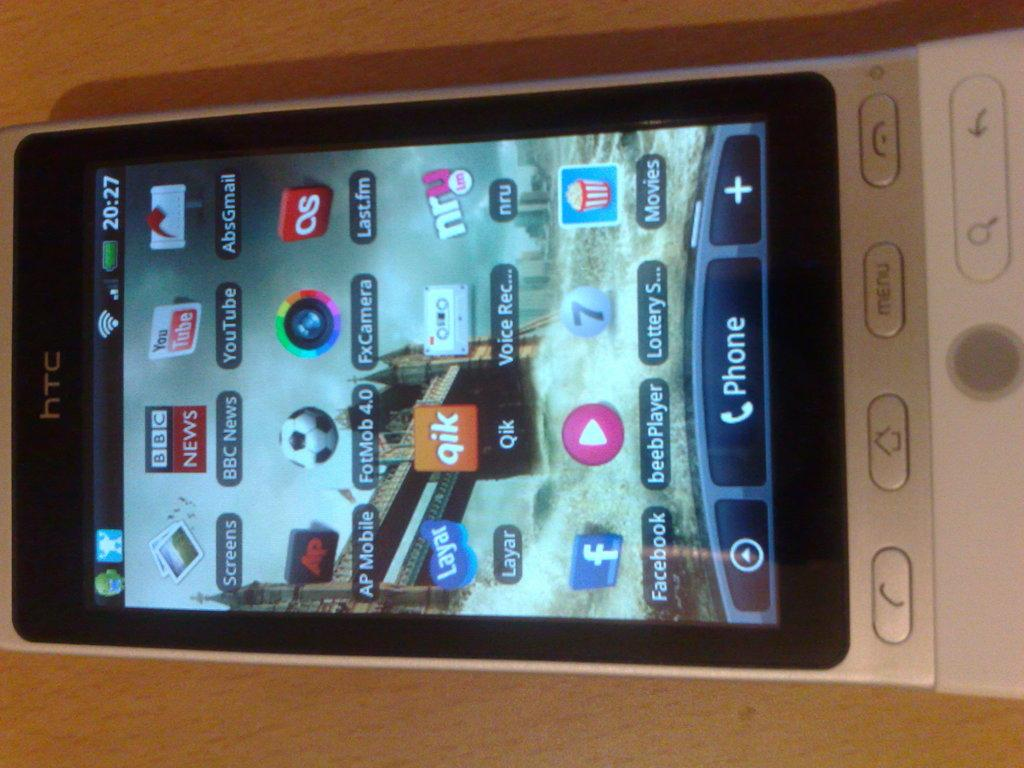<image>
Write a terse but informative summary of the picture. an htc phone with the qik app logo on the screen 